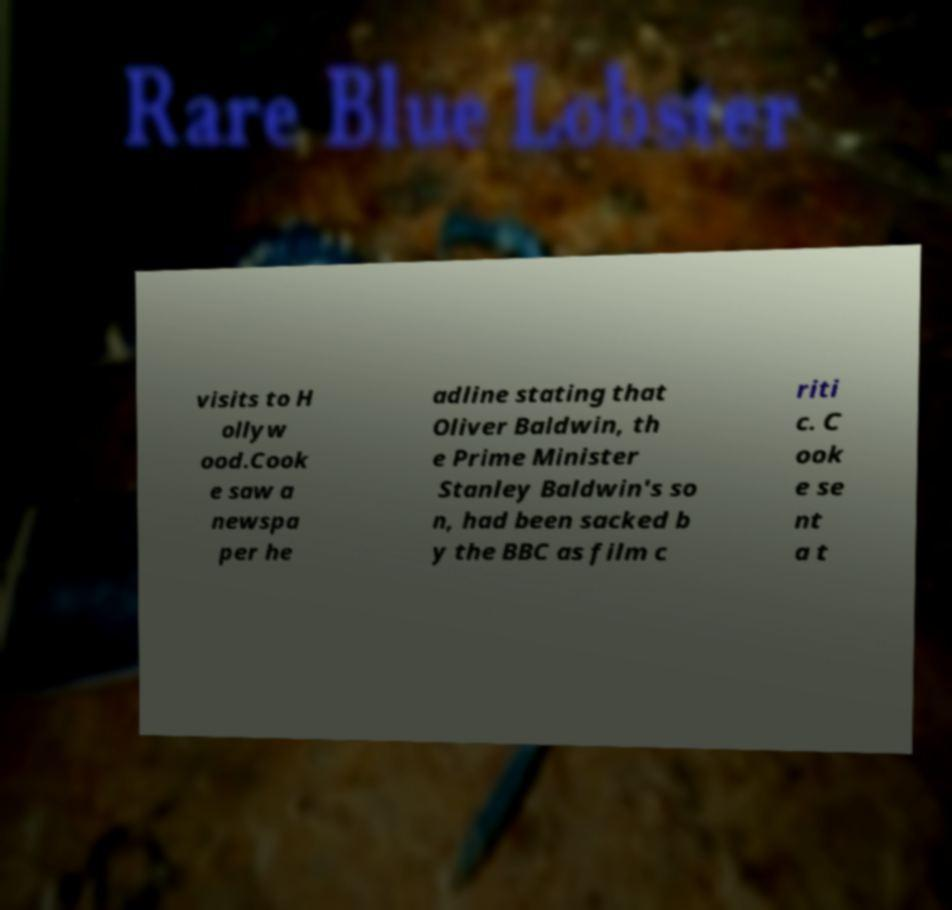Please read and relay the text visible in this image. What does it say? visits to H ollyw ood.Cook e saw a newspa per he adline stating that Oliver Baldwin, th e Prime Minister Stanley Baldwin's so n, had been sacked b y the BBC as film c riti c. C ook e se nt a t 